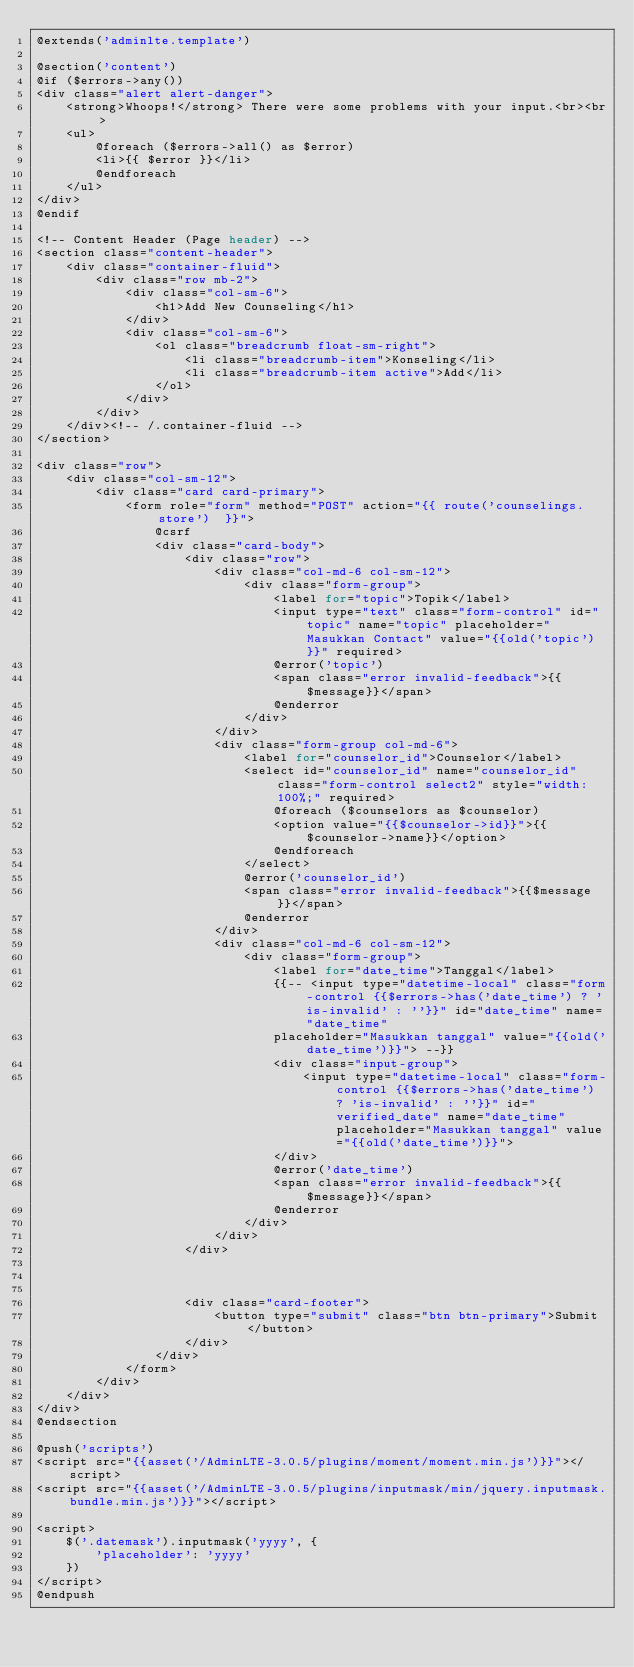<code> <loc_0><loc_0><loc_500><loc_500><_PHP_>@extends('adminlte.template')

@section('content')
@if ($errors->any())
<div class="alert alert-danger">
    <strong>Whoops!</strong> There were some problems with your input.<br><br>
    <ul>
        @foreach ($errors->all() as $error)
        <li>{{ $error }}</li>
        @endforeach
    </ul>
</div>
@endif

<!-- Content Header (Page header) -->
<section class="content-header">
    <div class="container-fluid">
        <div class="row mb-2">
            <div class="col-sm-6">
                <h1>Add New Counseling</h1>
            </div>
            <div class="col-sm-6">
                <ol class="breadcrumb float-sm-right">
                    <li class="breadcrumb-item">Konseling</li>
                    <li class="breadcrumb-item active">Add</li>
                </ol>
            </div>
        </div>
    </div><!-- /.container-fluid -->
</section>

<div class="row">
    <div class="col-sm-12">
        <div class="card card-primary">
            <form role="form" method="POST" action="{{ route('counselings.store')  }}">
                @csrf
                <div class="card-body">
                    <div class="row">
                        <div class="col-md-6 col-sm-12">
                            <div class="form-group">
                                <label for="topic">Topik</label>
                                <input type="text" class="form-control" id="topic" name="topic" placeholder="Masukkan Contact" value="{{old('topic')}}" required>
                                @error('topic')
                                <span class="error invalid-feedback">{{$message}}</span>
                                @enderror
                            </div>
                        </div>
                        <div class="form-group col-md-6">
                            <label for="counselor_id">Counselor</label>
                            <select id="counselor_id" name="counselor_id" class="form-control select2" style="width: 100%;" required>
                                @foreach ($counselors as $counselor)
                                <option value="{{$counselor->id}}">{{$counselor->name}}</option>
                                @endforeach
                            </select>
                            @error('counselor_id')
                            <span class="error invalid-feedback">{{$message}}</span>
                            @enderror
                        </div>
                        <div class="col-md-6 col-sm-12">
                            <div class="form-group">
                                <label for="date_time">Tanggal</label>
                                {{-- <input type="datetime-local" class="form-control {{$errors->has('date_time') ? 'is-invalid' : ''}}" id="date_time" name="date_time"
                                placeholder="Masukkan tanggal" value="{{old('date_time')}}"> --}}
                                <div class="input-group">
                                    <input type="datetime-local" class="form-control {{$errors->has('date_time') ? 'is-invalid' : ''}}" id="verified_date" name="date_time" placeholder="Masukkan tanggal" value="{{old('date_time')}}">
                                </div>
                                @error('date_time')
                                <span class="error invalid-feedback">{{$message}}</span>
                                @enderror
                            </div>
                        </div>
                    </div>



                    <div class="card-footer">
                        <button type="submit" class="btn btn-primary">Submit</button>
                    </div>
                </div>
            </form>
        </div>
    </div>
</div>
@endsection

@push('scripts')
<script src="{{asset('/AdminLTE-3.0.5/plugins/moment/moment.min.js')}}"></script>
<script src="{{asset('/AdminLTE-3.0.5/plugins/inputmask/min/jquery.inputmask.bundle.min.js')}}"></script>

<script>
    $('.datemask').inputmask('yyyy', {
        'placeholder': 'yyyy'
    })
</script>
@endpush</code> 